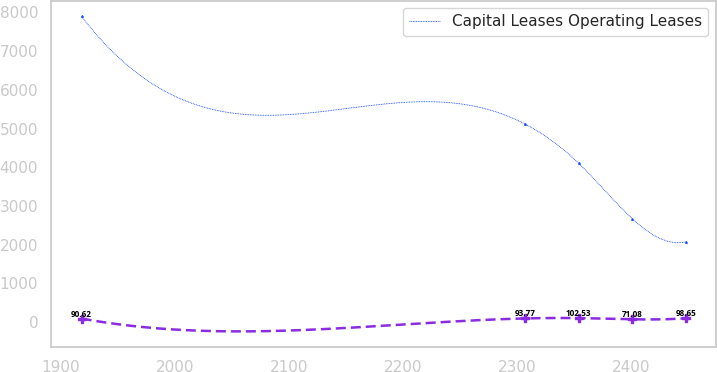<chart> <loc_0><loc_0><loc_500><loc_500><line_chart><ecel><fcel>Unnamed: 1<fcel>Capital Leases Operating Leases<nl><fcel>1918.06<fcel>90.62<fcel>7894.2<nl><fcel>2307.04<fcel>93.77<fcel>5114.56<nl><fcel>2354.01<fcel>102.53<fcel>4101.16<nl><fcel>2400.98<fcel>71.08<fcel>2671.11<nl><fcel>2447.95<fcel>98.65<fcel>2073.62<nl></chart> 